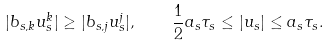<formula> <loc_0><loc_0><loc_500><loc_500>| b _ { s , k } u _ { s } ^ { k } | \geq | b _ { s , j } u _ { s } ^ { j } | , \quad \frac { 1 } { 2 } a _ { s } \tau _ { s } \leq | u _ { s } | \leq a _ { s } \tau _ { s } .</formula> 